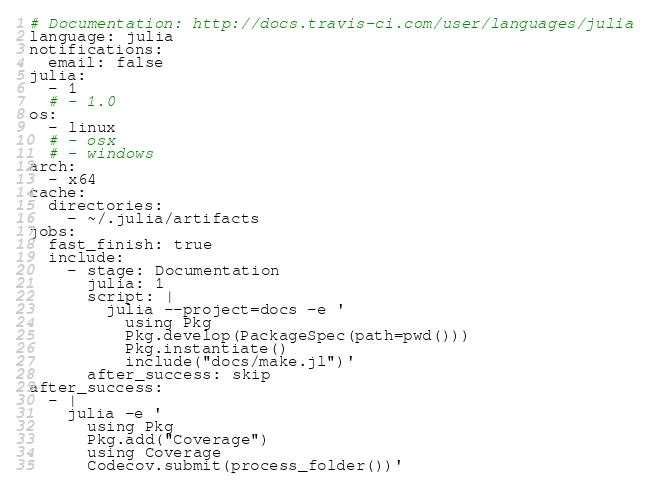<code> <loc_0><loc_0><loc_500><loc_500><_YAML_># Documentation: http://docs.travis-ci.com/user/languages/julia
language: julia
notifications:
  email: false
julia:
  - 1
  # - 1.0
os:
  - linux
  # - osx
  # - windows
arch:
  - x64
cache:
  directories:
    - ~/.julia/artifacts
jobs:
  fast_finish: true
  include:
    - stage: Documentation
      julia: 1
      script: |
        julia --project=docs -e '
          using Pkg
          Pkg.develop(PackageSpec(path=pwd()))
          Pkg.instantiate()
          include("docs/make.jl")'
      after_success: skip
after_success:
  - |
    julia -e '
      using Pkg
      Pkg.add("Coverage")
      using Coverage
      Codecov.submit(process_folder())'
</code> 